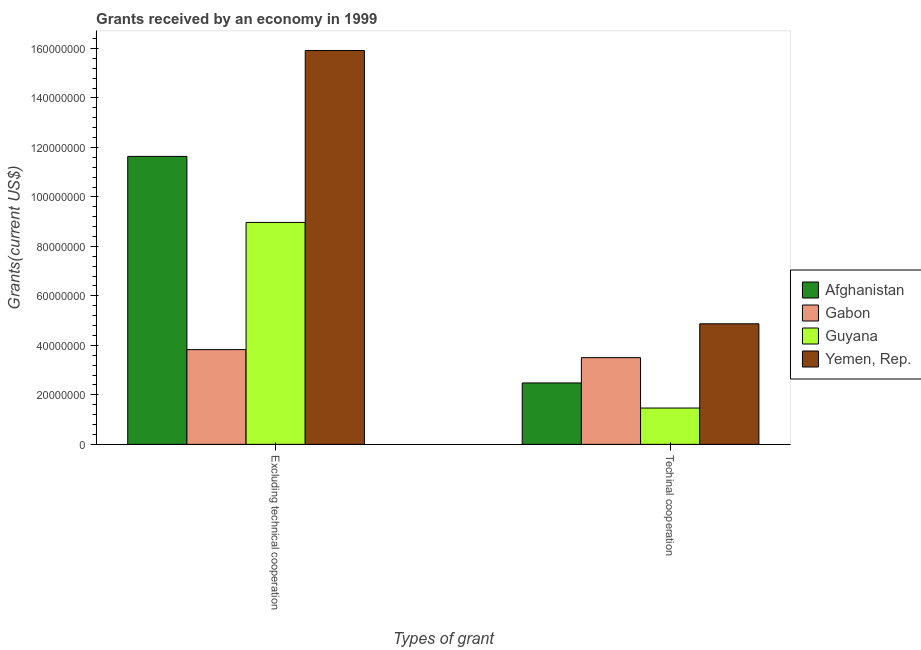How many bars are there on the 1st tick from the left?
Offer a very short reply. 4. How many bars are there on the 1st tick from the right?
Make the answer very short. 4. What is the label of the 1st group of bars from the left?
Offer a very short reply. Excluding technical cooperation. What is the amount of grants received(excluding technical cooperation) in Afghanistan?
Provide a succinct answer. 1.16e+08. Across all countries, what is the maximum amount of grants received(including technical cooperation)?
Provide a succinct answer. 4.87e+07. Across all countries, what is the minimum amount of grants received(including technical cooperation)?
Ensure brevity in your answer.  1.47e+07. In which country was the amount of grants received(including technical cooperation) maximum?
Offer a terse response. Yemen, Rep. In which country was the amount of grants received(excluding technical cooperation) minimum?
Offer a terse response. Gabon. What is the total amount of grants received(excluding technical cooperation) in the graph?
Your response must be concise. 4.04e+08. What is the difference between the amount of grants received(excluding technical cooperation) in Afghanistan and that in Guyana?
Ensure brevity in your answer.  2.67e+07. What is the difference between the amount of grants received(including technical cooperation) in Afghanistan and the amount of grants received(excluding technical cooperation) in Gabon?
Your answer should be compact. -1.35e+07. What is the average amount of grants received(including technical cooperation) per country?
Offer a terse response. 3.08e+07. What is the difference between the amount of grants received(including technical cooperation) and amount of grants received(excluding technical cooperation) in Gabon?
Provide a succinct answer. -3.24e+06. What is the ratio of the amount of grants received(excluding technical cooperation) in Gabon to that in Afghanistan?
Provide a short and direct response. 0.33. Is the amount of grants received(excluding technical cooperation) in Guyana less than that in Yemen, Rep.?
Your answer should be very brief. Yes. What does the 3rd bar from the left in Excluding technical cooperation represents?
Your answer should be compact. Guyana. What does the 2nd bar from the right in Excluding technical cooperation represents?
Make the answer very short. Guyana. How many bars are there?
Provide a succinct answer. 8. Are all the bars in the graph horizontal?
Give a very brief answer. No. What is the difference between two consecutive major ticks on the Y-axis?
Offer a terse response. 2.00e+07. Does the graph contain any zero values?
Your answer should be very brief. No. What is the title of the graph?
Provide a succinct answer. Grants received by an economy in 1999. What is the label or title of the X-axis?
Your answer should be very brief. Types of grant. What is the label or title of the Y-axis?
Offer a terse response. Grants(current US$). What is the Grants(current US$) of Afghanistan in Excluding technical cooperation?
Ensure brevity in your answer.  1.16e+08. What is the Grants(current US$) in Gabon in Excluding technical cooperation?
Offer a terse response. 3.83e+07. What is the Grants(current US$) of Guyana in Excluding technical cooperation?
Offer a terse response. 8.97e+07. What is the Grants(current US$) of Yemen, Rep. in Excluding technical cooperation?
Ensure brevity in your answer.  1.59e+08. What is the Grants(current US$) in Afghanistan in Techinal cooperation?
Offer a terse response. 2.48e+07. What is the Grants(current US$) of Gabon in Techinal cooperation?
Offer a terse response. 3.50e+07. What is the Grants(current US$) of Guyana in Techinal cooperation?
Your answer should be very brief. 1.47e+07. What is the Grants(current US$) of Yemen, Rep. in Techinal cooperation?
Keep it short and to the point. 4.87e+07. Across all Types of grant, what is the maximum Grants(current US$) of Afghanistan?
Provide a short and direct response. 1.16e+08. Across all Types of grant, what is the maximum Grants(current US$) in Gabon?
Provide a short and direct response. 3.83e+07. Across all Types of grant, what is the maximum Grants(current US$) in Guyana?
Your answer should be very brief. 8.97e+07. Across all Types of grant, what is the maximum Grants(current US$) in Yemen, Rep.?
Your response must be concise. 1.59e+08. Across all Types of grant, what is the minimum Grants(current US$) of Afghanistan?
Your answer should be very brief. 2.48e+07. Across all Types of grant, what is the minimum Grants(current US$) of Gabon?
Your answer should be very brief. 3.50e+07. Across all Types of grant, what is the minimum Grants(current US$) in Guyana?
Give a very brief answer. 1.47e+07. Across all Types of grant, what is the minimum Grants(current US$) of Yemen, Rep.?
Provide a short and direct response. 4.87e+07. What is the total Grants(current US$) in Afghanistan in the graph?
Provide a short and direct response. 1.41e+08. What is the total Grants(current US$) of Gabon in the graph?
Your answer should be very brief. 7.33e+07. What is the total Grants(current US$) in Guyana in the graph?
Your answer should be very brief. 1.04e+08. What is the total Grants(current US$) of Yemen, Rep. in the graph?
Your response must be concise. 2.08e+08. What is the difference between the Grants(current US$) in Afghanistan in Excluding technical cooperation and that in Techinal cooperation?
Offer a terse response. 9.16e+07. What is the difference between the Grants(current US$) in Gabon in Excluding technical cooperation and that in Techinal cooperation?
Make the answer very short. 3.24e+06. What is the difference between the Grants(current US$) of Guyana in Excluding technical cooperation and that in Techinal cooperation?
Provide a short and direct response. 7.50e+07. What is the difference between the Grants(current US$) in Yemen, Rep. in Excluding technical cooperation and that in Techinal cooperation?
Keep it short and to the point. 1.10e+08. What is the difference between the Grants(current US$) in Afghanistan in Excluding technical cooperation and the Grants(current US$) in Gabon in Techinal cooperation?
Offer a terse response. 8.13e+07. What is the difference between the Grants(current US$) in Afghanistan in Excluding technical cooperation and the Grants(current US$) in Guyana in Techinal cooperation?
Provide a short and direct response. 1.02e+08. What is the difference between the Grants(current US$) of Afghanistan in Excluding technical cooperation and the Grants(current US$) of Yemen, Rep. in Techinal cooperation?
Provide a short and direct response. 6.76e+07. What is the difference between the Grants(current US$) in Gabon in Excluding technical cooperation and the Grants(current US$) in Guyana in Techinal cooperation?
Give a very brief answer. 2.36e+07. What is the difference between the Grants(current US$) in Gabon in Excluding technical cooperation and the Grants(current US$) in Yemen, Rep. in Techinal cooperation?
Your answer should be compact. -1.04e+07. What is the difference between the Grants(current US$) of Guyana in Excluding technical cooperation and the Grants(current US$) of Yemen, Rep. in Techinal cooperation?
Provide a short and direct response. 4.10e+07. What is the average Grants(current US$) in Afghanistan per Types of grant?
Provide a short and direct response. 7.06e+07. What is the average Grants(current US$) of Gabon per Types of grant?
Ensure brevity in your answer.  3.67e+07. What is the average Grants(current US$) in Guyana per Types of grant?
Keep it short and to the point. 5.22e+07. What is the average Grants(current US$) in Yemen, Rep. per Types of grant?
Your response must be concise. 1.04e+08. What is the difference between the Grants(current US$) of Afghanistan and Grants(current US$) of Gabon in Excluding technical cooperation?
Make the answer very short. 7.81e+07. What is the difference between the Grants(current US$) of Afghanistan and Grants(current US$) of Guyana in Excluding technical cooperation?
Your answer should be compact. 2.67e+07. What is the difference between the Grants(current US$) of Afghanistan and Grants(current US$) of Yemen, Rep. in Excluding technical cooperation?
Offer a very short reply. -4.28e+07. What is the difference between the Grants(current US$) of Gabon and Grants(current US$) of Guyana in Excluding technical cooperation?
Ensure brevity in your answer.  -5.14e+07. What is the difference between the Grants(current US$) in Gabon and Grants(current US$) in Yemen, Rep. in Excluding technical cooperation?
Provide a succinct answer. -1.21e+08. What is the difference between the Grants(current US$) of Guyana and Grants(current US$) of Yemen, Rep. in Excluding technical cooperation?
Your answer should be compact. -6.95e+07. What is the difference between the Grants(current US$) of Afghanistan and Grants(current US$) of Gabon in Techinal cooperation?
Your response must be concise. -1.02e+07. What is the difference between the Grants(current US$) of Afghanistan and Grants(current US$) of Guyana in Techinal cooperation?
Provide a short and direct response. 1.01e+07. What is the difference between the Grants(current US$) in Afghanistan and Grants(current US$) in Yemen, Rep. in Techinal cooperation?
Make the answer very short. -2.39e+07. What is the difference between the Grants(current US$) in Gabon and Grants(current US$) in Guyana in Techinal cooperation?
Provide a short and direct response. 2.04e+07. What is the difference between the Grants(current US$) of Gabon and Grants(current US$) of Yemen, Rep. in Techinal cooperation?
Give a very brief answer. -1.37e+07. What is the difference between the Grants(current US$) in Guyana and Grants(current US$) in Yemen, Rep. in Techinal cooperation?
Provide a short and direct response. -3.40e+07. What is the ratio of the Grants(current US$) of Afghanistan in Excluding technical cooperation to that in Techinal cooperation?
Offer a very short reply. 4.69. What is the ratio of the Grants(current US$) of Gabon in Excluding technical cooperation to that in Techinal cooperation?
Provide a short and direct response. 1.09. What is the ratio of the Grants(current US$) of Guyana in Excluding technical cooperation to that in Techinal cooperation?
Provide a succinct answer. 6.11. What is the ratio of the Grants(current US$) in Yemen, Rep. in Excluding technical cooperation to that in Techinal cooperation?
Make the answer very short. 3.27. What is the difference between the highest and the second highest Grants(current US$) in Afghanistan?
Your answer should be compact. 9.16e+07. What is the difference between the highest and the second highest Grants(current US$) in Gabon?
Give a very brief answer. 3.24e+06. What is the difference between the highest and the second highest Grants(current US$) in Guyana?
Your answer should be very brief. 7.50e+07. What is the difference between the highest and the second highest Grants(current US$) of Yemen, Rep.?
Your answer should be compact. 1.10e+08. What is the difference between the highest and the lowest Grants(current US$) of Afghanistan?
Offer a very short reply. 9.16e+07. What is the difference between the highest and the lowest Grants(current US$) in Gabon?
Keep it short and to the point. 3.24e+06. What is the difference between the highest and the lowest Grants(current US$) of Guyana?
Offer a very short reply. 7.50e+07. What is the difference between the highest and the lowest Grants(current US$) of Yemen, Rep.?
Make the answer very short. 1.10e+08. 